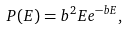Convert formula to latex. <formula><loc_0><loc_0><loc_500><loc_500>P ( E ) = b ^ { 2 } E e ^ { - b E } ,</formula> 